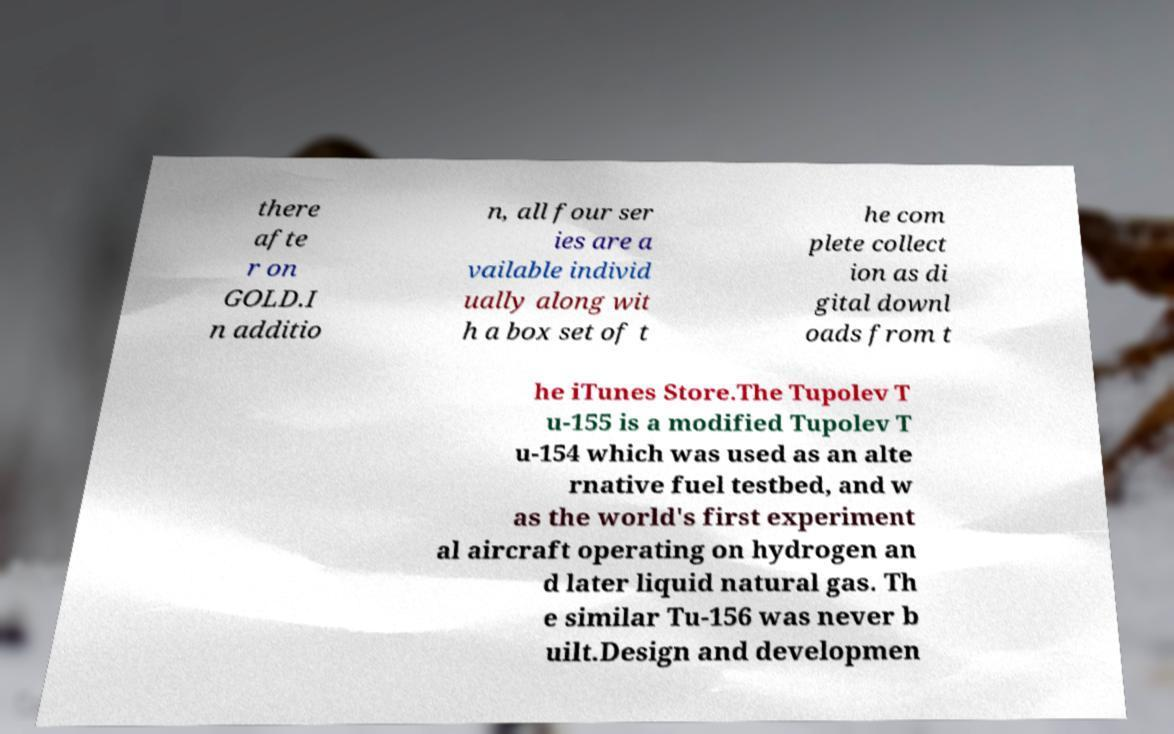I need the written content from this picture converted into text. Can you do that? there afte r on GOLD.I n additio n, all four ser ies are a vailable individ ually along wit h a box set of t he com plete collect ion as di gital downl oads from t he iTunes Store.The Tupolev T u-155 is a modified Tupolev T u-154 which was used as an alte rnative fuel testbed, and w as the world's first experiment al aircraft operating on hydrogen an d later liquid natural gas. Th e similar Tu-156 was never b uilt.Design and developmen 